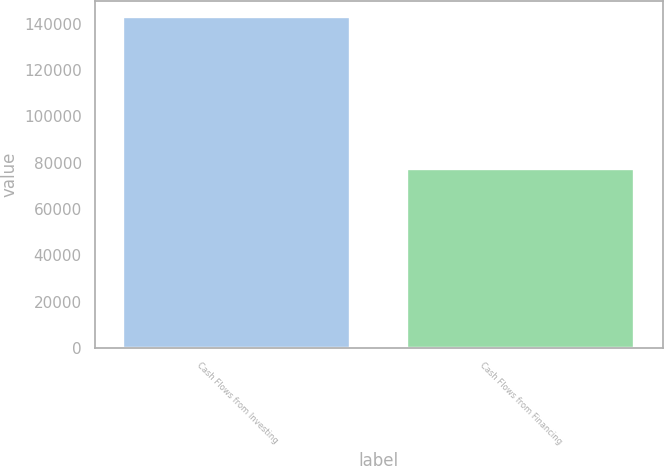<chart> <loc_0><loc_0><loc_500><loc_500><bar_chart><fcel>Cash Flows from Investing<fcel>Cash Flows from Financing<nl><fcel>142760<fcel>77258<nl></chart> 